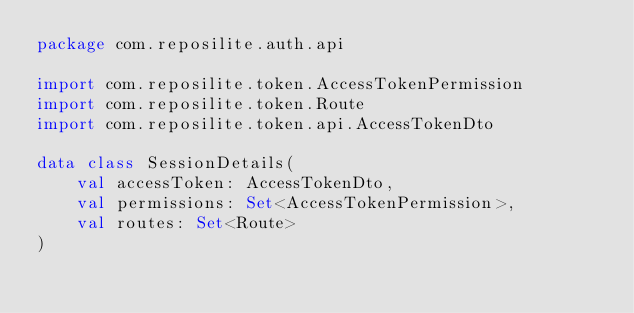<code> <loc_0><loc_0><loc_500><loc_500><_Kotlin_>package com.reposilite.auth.api

import com.reposilite.token.AccessTokenPermission
import com.reposilite.token.Route
import com.reposilite.token.api.AccessTokenDto

data class SessionDetails(
    val accessToken: AccessTokenDto,
    val permissions: Set<AccessTokenPermission>,
    val routes: Set<Route>
)</code> 